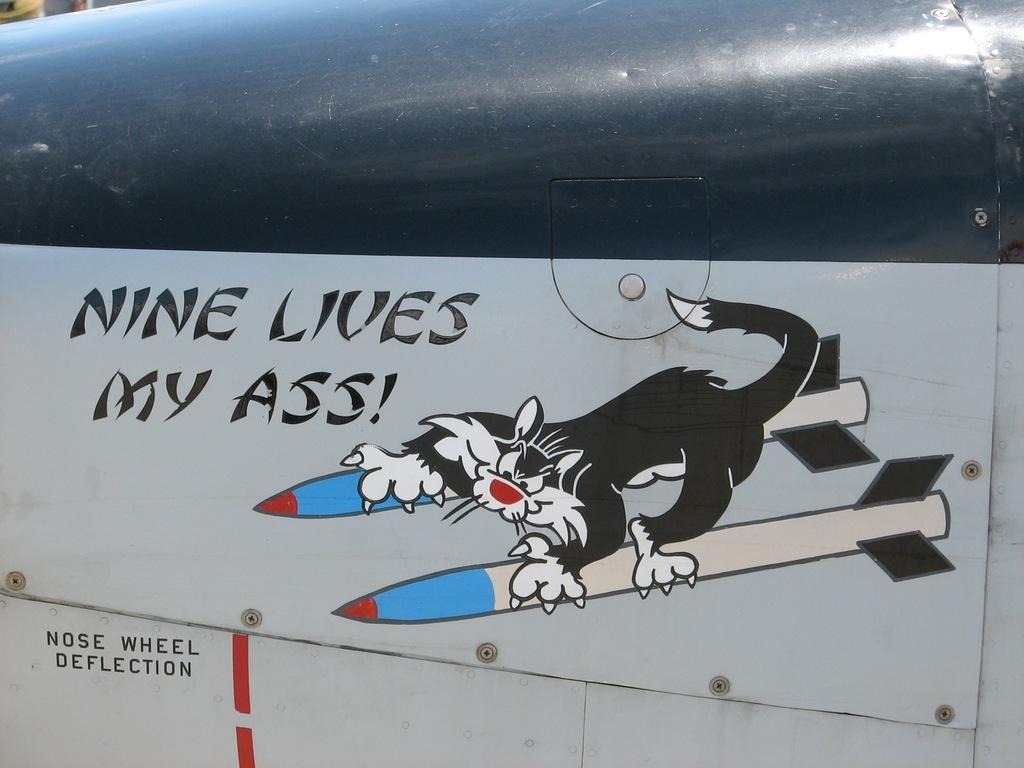Could you give a brief overview of what you see in this image? In this picture we can see text and art on the metal. 